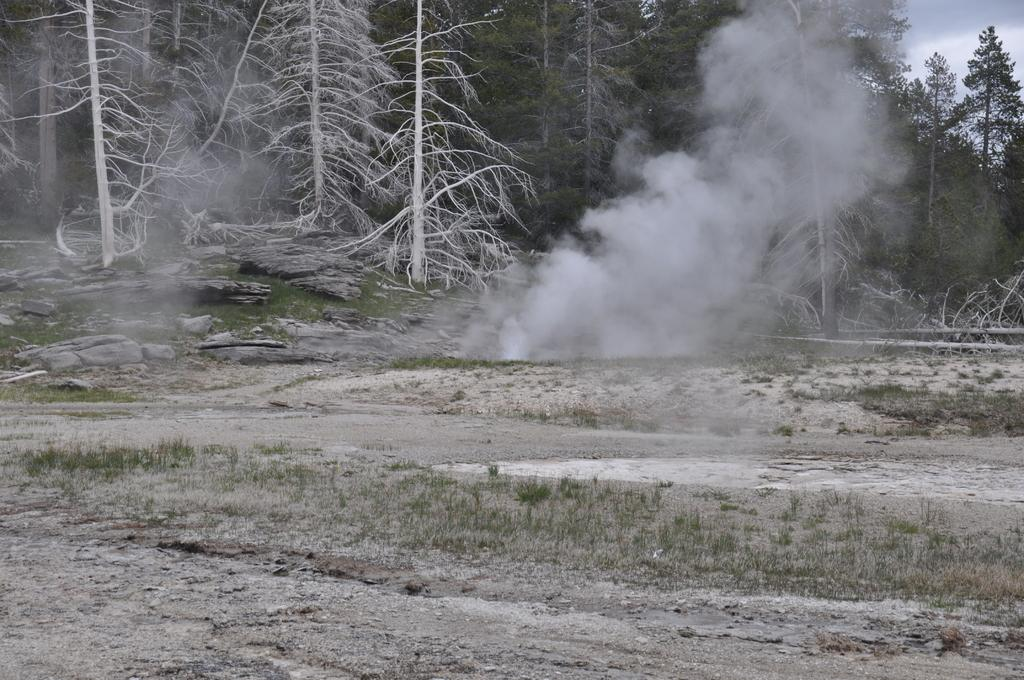What is present on the path in the image? There are plants and stones on the path in the image. What can be seen in the air in the image? There is smoke visible in the air in the image. What type of vegetation is visible in the background of the image? There are trees in the background of the image. Where is the shop located in the image? There is no shop present in the image. What type of fruit can be seen hanging from the trees in the image? There is no fruit visible in the image; only trees are present in the background. 